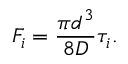Convert formula to latex. <formula><loc_0><loc_0><loc_500><loc_500>F _ { i } = \frac { \pi d ^ { 3 } } { 8 D } \tau _ { i } .</formula> 